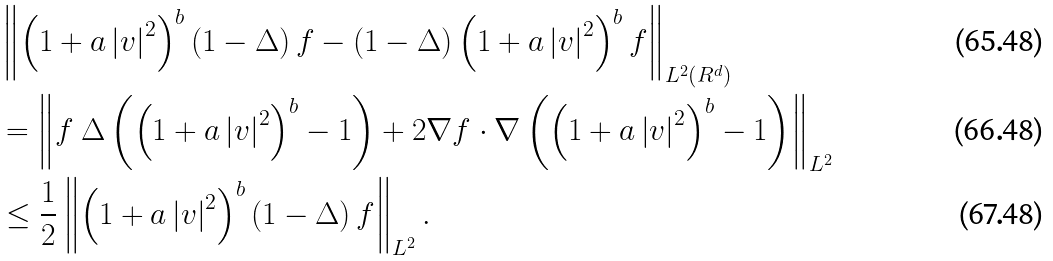Convert formula to latex. <formula><loc_0><loc_0><loc_500><loc_500>& \left \| \left ( 1 + a \left | v \right | ^ { 2 } \right ) ^ { b } \left ( 1 - \Delta \right ) f - \left ( 1 - \Delta \right ) \left ( 1 + a \left | v \right | ^ { 2 } \right ) ^ { b } f \right \| _ { L ^ { 2 } \left ( R ^ { d } \right ) } \\ & = \left \| f \ \Delta \left ( \left ( 1 + a \left | v \right | ^ { 2 } \right ) ^ { b } - 1 \right ) + 2 \nabla f \cdot \nabla \left ( \left ( 1 + a \left | v \right | ^ { 2 } \right ) ^ { b } - 1 \right ) \right \| _ { L ^ { 2 } } \\ & \leq \frac { 1 } { 2 } \left \| \left ( 1 + a \left | v \right | ^ { 2 } \right ) ^ { b } \left ( 1 - \Delta \right ) f \right \| _ { L ^ { 2 } } .</formula> 